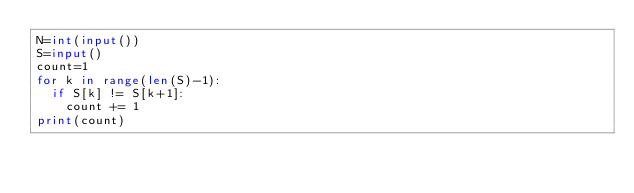Convert code to text. <code><loc_0><loc_0><loc_500><loc_500><_Python_>N=int(input())
S=input()
count=1
for k in range(len(S)-1):
  if S[k] != S[k+1]:
    count += 1
print(count)</code> 